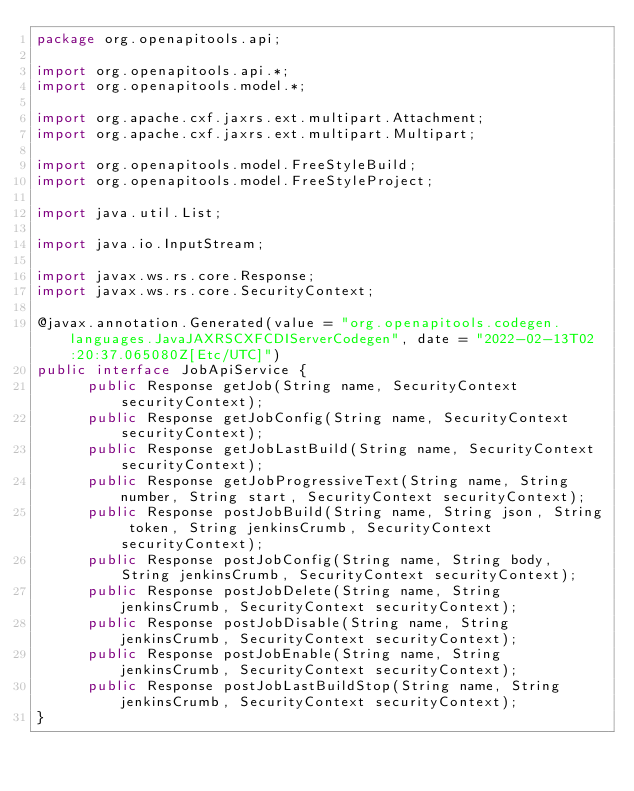<code> <loc_0><loc_0><loc_500><loc_500><_Java_>package org.openapitools.api;

import org.openapitools.api.*;
import org.openapitools.model.*;

import org.apache.cxf.jaxrs.ext.multipart.Attachment;
import org.apache.cxf.jaxrs.ext.multipart.Multipart;

import org.openapitools.model.FreeStyleBuild;
import org.openapitools.model.FreeStyleProject;

import java.util.List;

import java.io.InputStream;

import javax.ws.rs.core.Response;
import javax.ws.rs.core.SecurityContext;

@javax.annotation.Generated(value = "org.openapitools.codegen.languages.JavaJAXRSCXFCDIServerCodegen", date = "2022-02-13T02:20:37.065080Z[Etc/UTC]")
public interface JobApiService {
      public Response getJob(String name, SecurityContext securityContext);
      public Response getJobConfig(String name, SecurityContext securityContext);
      public Response getJobLastBuild(String name, SecurityContext securityContext);
      public Response getJobProgressiveText(String name, String number, String start, SecurityContext securityContext);
      public Response postJobBuild(String name, String json, String token, String jenkinsCrumb, SecurityContext securityContext);
      public Response postJobConfig(String name, String body, String jenkinsCrumb, SecurityContext securityContext);
      public Response postJobDelete(String name, String jenkinsCrumb, SecurityContext securityContext);
      public Response postJobDisable(String name, String jenkinsCrumb, SecurityContext securityContext);
      public Response postJobEnable(String name, String jenkinsCrumb, SecurityContext securityContext);
      public Response postJobLastBuildStop(String name, String jenkinsCrumb, SecurityContext securityContext);
}
</code> 